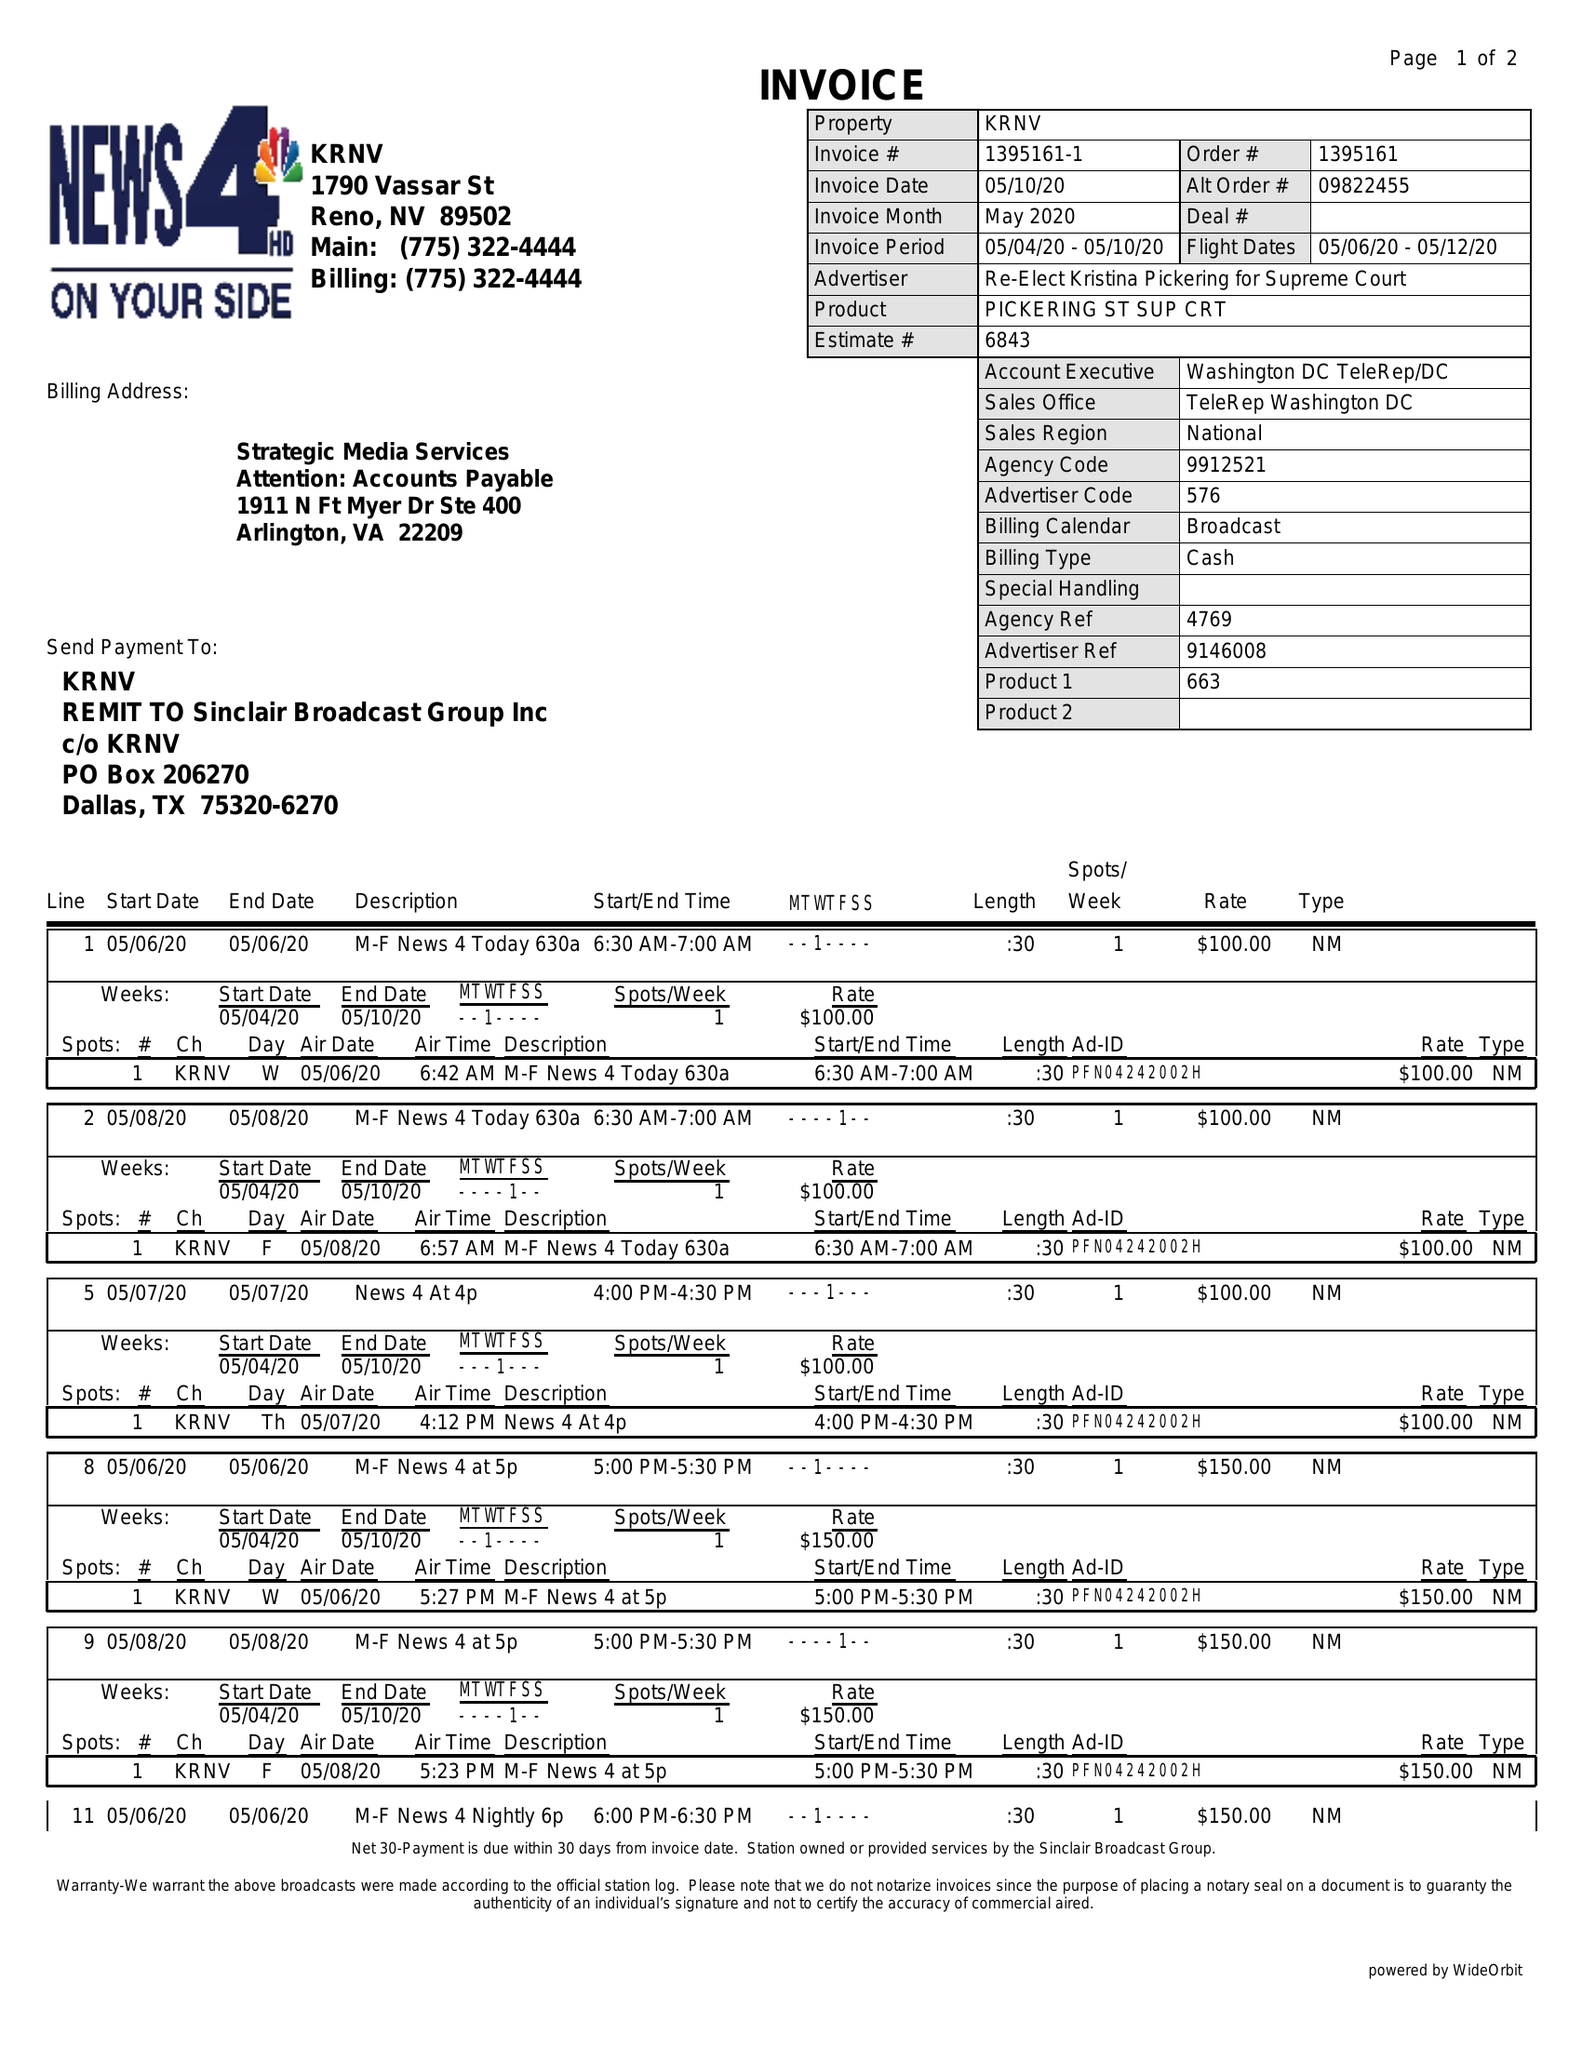What is the value for the flight_from?
Answer the question using a single word or phrase. 05/06/20 